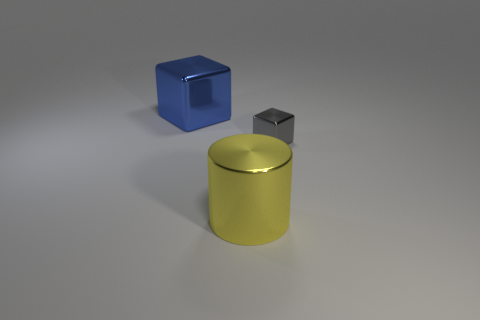Add 2 cyan metal blocks. How many objects exist? 5 Subtract all blocks. How many objects are left? 1 Subtract all large blue things. Subtract all blue blocks. How many objects are left? 1 Add 1 cylinders. How many cylinders are left? 2 Add 2 big yellow metal things. How many big yellow metal things exist? 3 Subtract 1 gray cubes. How many objects are left? 2 